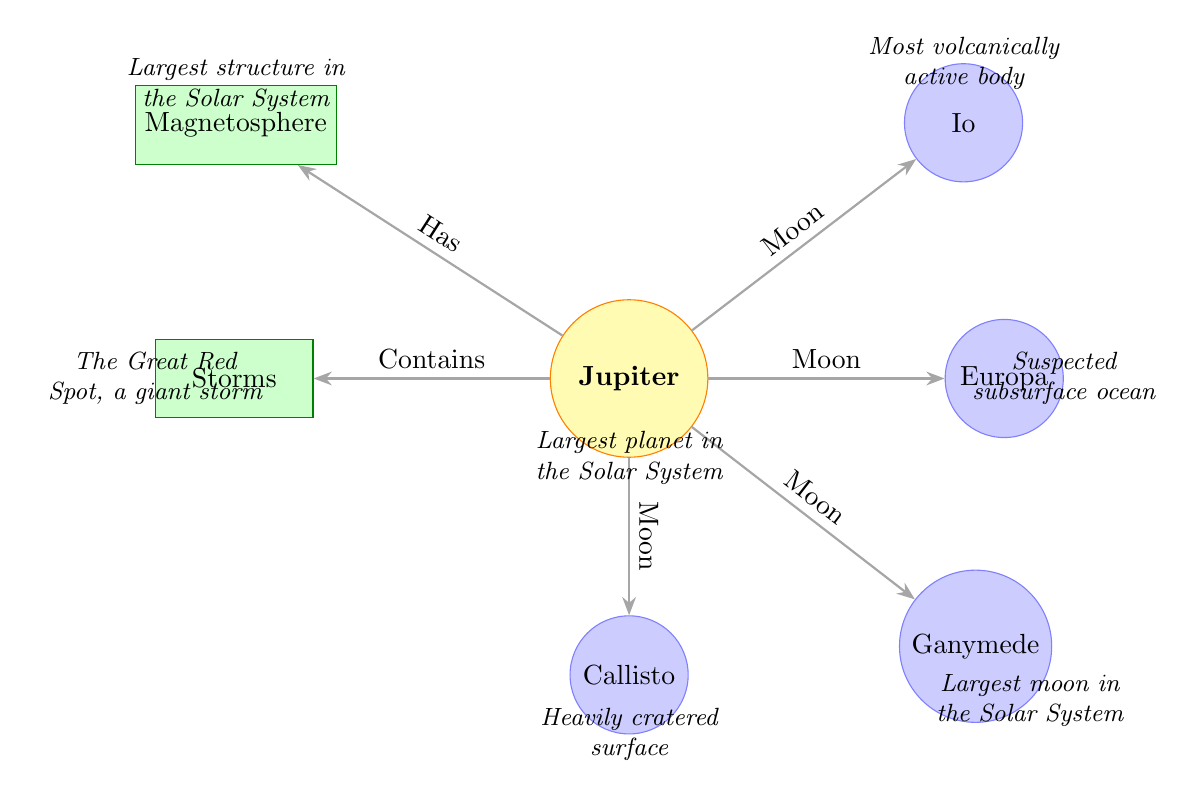What is the name of the largest planet in the Solar System? The diagram identifies Jupiter as the largest planet in the Solar System, as indicated at the bottom of the Jupiter node.
Answer: Jupiter How many moons are shown in the diagram? The diagram visually displays four moons connected to Jupiter, which are Io, Europa, Ganymede, and Callisto.
Answer: 4 What is the unique feature of Io? The diagram states that Io is the most volcanically active body, which is noted as an additional information point positioned north of the Io node.
Answer: Most volcanically active body What structure is described as the largest in the Solar System? The magnetosphere is indicated as the largest structure in the Solar System, which is noted at the north of the Magnetosphere node in the diagram.
Answer: Magnetosphere What characteristic is attributed to Ganymede? According to the diagram, Ganymede is described as the largest moon in the Solar System, as shown with an additional information point situated southeast of the Ganymede node.
Answer: Largest moon in the Solar System Which moon is suspected to have a subsurface ocean? The diagram specifies that Europa is suspected to have a subsurface ocean, indicated by the information point located east of the Europa node.
Answer: Suspected subsurface ocean Which feature of Jupiter is referred to as a giant storm? The diagram mentions "The Great Red Spot, a giant storm" as an additional feature of Jupiter, positioned to the west of the Storms node.
Answer: The Great Red Spot What does the diagram suggest about Jupiter's storms? The diagram states that Jupiter "Contains" storms, indicated by the directional connection from the Jupiter node to the Storms node.
Answer: Contains storms How does Jupiter's magnetosphere relate to its moons? The diagram connects Jupiter to its moons and the magnetosphere; this suggests that the moons operate within the influence of Jupiter's magnetosphere.
Answer: Operate within influence What does the diagram convey about Callisto's surface? The additional information point indicates Callisto has a heavily cratered surface, thus conveying a visual description about its characteristics.
Answer: Heavily cratered surface 